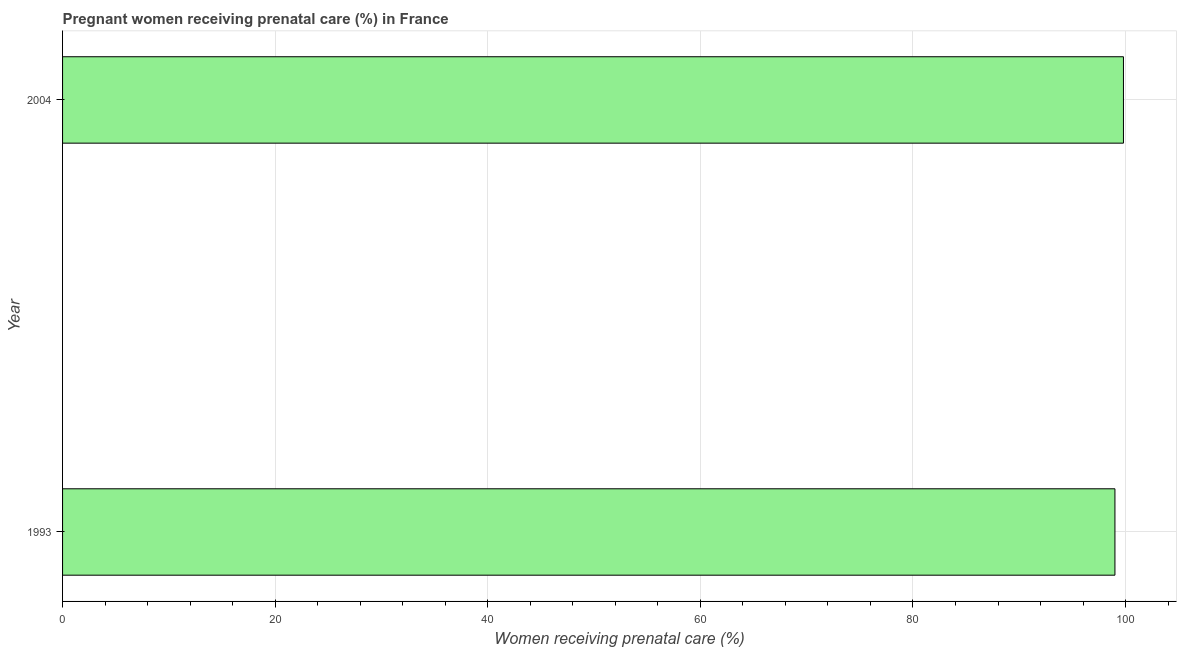Does the graph contain any zero values?
Your answer should be very brief. No. Does the graph contain grids?
Your response must be concise. Yes. What is the title of the graph?
Your answer should be compact. Pregnant women receiving prenatal care (%) in France. What is the label or title of the X-axis?
Give a very brief answer. Women receiving prenatal care (%). What is the label or title of the Y-axis?
Your answer should be very brief. Year. What is the percentage of pregnant women receiving prenatal care in 2004?
Ensure brevity in your answer.  99.8. Across all years, what is the maximum percentage of pregnant women receiving prenatal care?
Ensure brevity in your answer.  99.8. What is the sum of the percentage of pregnant women receiving prenatal care?
Offer a very short reply. 198.8. What is the average percentage of pregnant women receiving prenatal care per year?
Keep it short and to the point. 99.4. What is the median percentage of pregnant women receiving prenatal care?
Provide a succinct answer. 99.4. In how many years, is the percentage of pregnant women receiving prenatal care greater than the average percentage of pregnant women receiving prenatal care taken over all years?
Make the answer very short. 1. Are all the bars in the graph horizontal?
Your response must be concise. Yes. Are the values on the major ticks of X-axis written in scientific E-notation?
Your answer should be compact. No. What is the Women receiving prenatal care (%) of 1993?
Your answer should be very brief. 99. What is the Women receiving prenatal care (%) of 2004?
Keep it short and to the point. 99.8. What is the difference between the Women receiving prenatal care (%) in 1993 and 2004?
Provide a short and direct response. -0.8. 